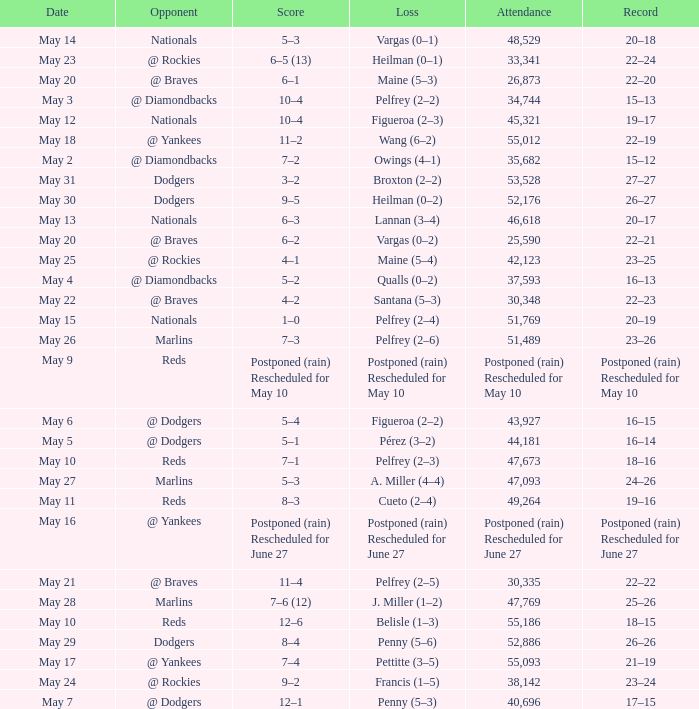Score of postponed (rain) rescheduled for June 27 had what loss? Postponed (rain) Rescheduled for June 27. 